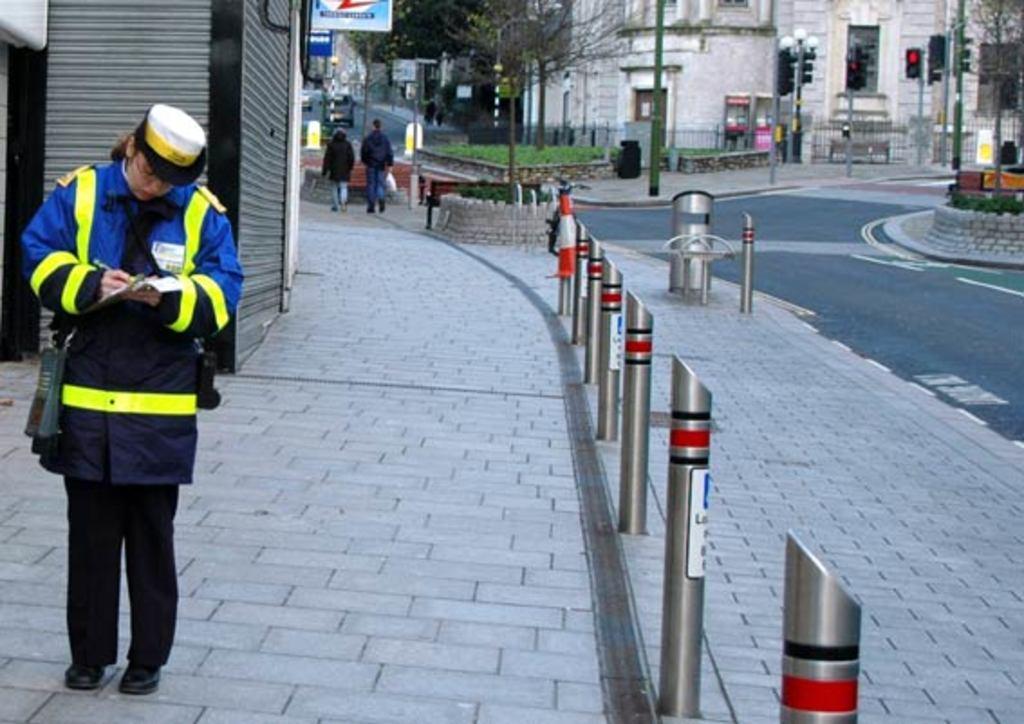Could you give a brief overview of what you see in this image? In the picture I can see a man wearing uniform is standing on the left side of the image, here I can see poles, two persons walking on the road, I can see boards, traffic signal poles, I can see trees, fence and buildings in the background. 